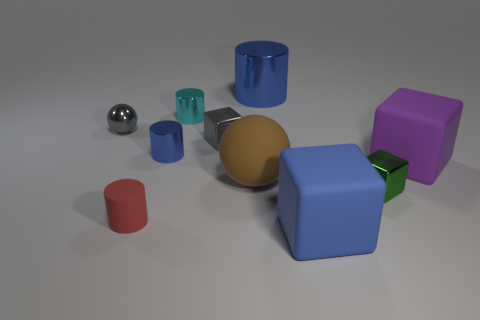Can you describe the arrangement of the objects in relation to the large blue cube? Certainly! The large blue cube is centrally located within the scene. To its left, there is a small blue cylinder and a metallic sphere closely placed. In front of the cube sits a golden sphere, while to the right, we find a small teal cube and, further away, a large purple cube. None of the objects touch the large blue cube; they are all spatially independent. 